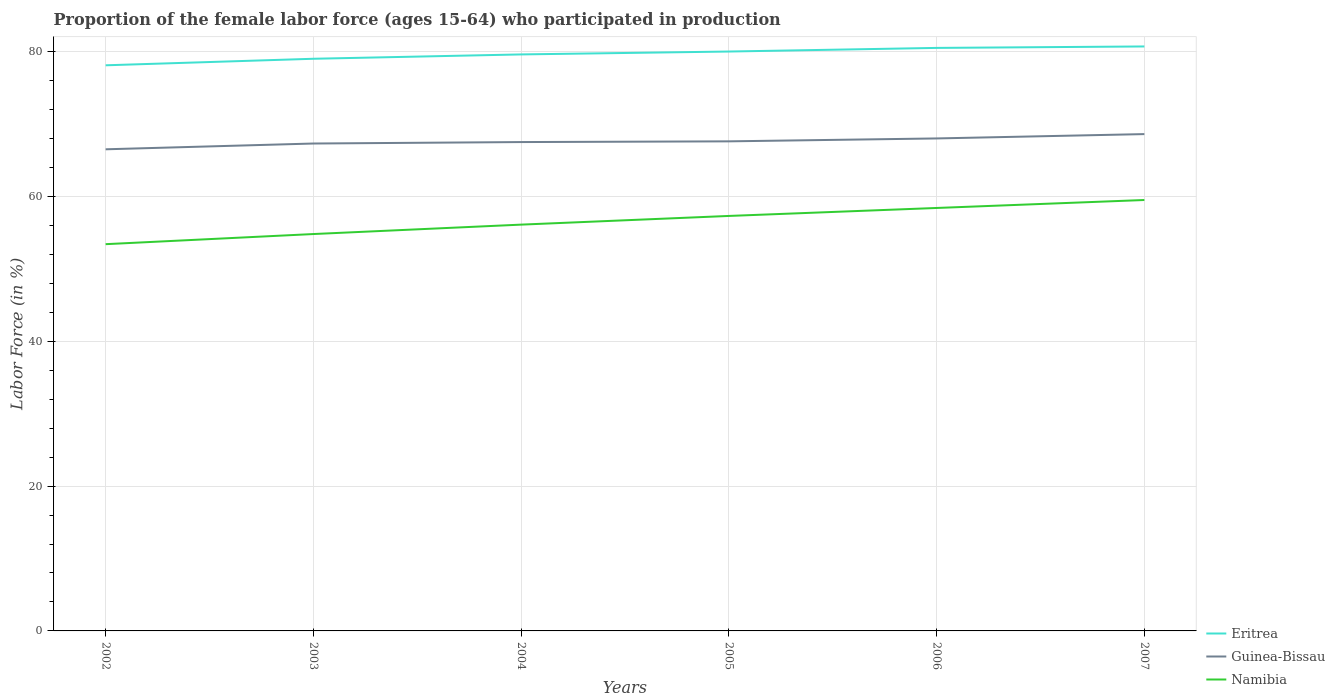How many different coloured lines are there?
Your answer should be very brief. 3. Across all years, what is the maximum proportion of the female labor force who participated in production in Namibia?
Give a very brief answer. 53.4. What is the total proportion of the female labor force who participated in production in Eritrea in the graph?
Offer a very short reply. -2.4. What is the difference between the highest and the second highest proportion of the female labor force who participated in production in Eritrea?
Provide a short and direct response. 2.6. How many lines are there?
Your response must be concise. 3. How many years are there in the graph?
Your answer should be very brief. 6. What is the difference between two consecutive major ticks on the Y-axis?
Offer a terse response. 20. Are the values on the major ticks of Y-axis written in scientific E-notation?
Make the answer very short. No. Does the graph contain any zero values?
Your answer should be very brief. No. How many legend labels are there?
Your response must be concise. 3. How are the legend labels stacked?
Give a very brief answer. Vertical. What is the title of the graph?
Keep it short and to the point. Proportion of the female labor force (ages 15-64) who participated in production. What is the label or title of the Y-axis?
Ensure brevity in your answer.  Labor Force (in %). What is the Labor Force (in %) of Eritrea in 2002?
Ensure brevity in your answer.  78.1. What is the Labor Force (in %) in Guinea-Bissau in 2002?
Your answer should be compact. 66.5. What is the Labor Force (in %) in Namibia in 2002?
Offer a very short reply. 53.4. What is the Labor Force (in %) of Eritrea in 2003?
Your answer should be compact. 79. What is the Labor Force (in %) in Guinea-Bissau in 2003?
Ensure brevity in your answer.  67.3. What is the Labor Force (in %) in Namibia in 2003?
Your answer should be very brief. 54.8. What is the Labor Force (in %) in Eritrea in 2004?
Your response must be concise. 79.6. What is the Labor Force (in %) of Guinea-Bissau in 2004?
Provide a short and direct response. 67.5. What is the Labor Force (in %) in Namibia in 2004?
Provide a short and direct response. 56.1. What is the Labor Force (in %) in Guinea-Bissau in 2005?
Ensure brevity in your answer.  67.6. What is the Labor Force (in %) of Namibia in 2005?
Make the answer very short. 57.3. What is the Labor Force (in %) in Eritrea in 2006?
Your response must be concise. 80.5. What is the Labor Force (in %) in Namibia in 2006?
Your response must be concise. 58.4. What is the Labor Force (in %) of Eritrea in 2007?
Provide a succinct answer. 80.7. What is the Labor Force (in %) in Guinea-Bissau in 2007?
Your answer should be compact. 68.6. What is the Labor Force (in %) of Namibia in 2007?
Your answer should be compact. 59.5. Across all years, what is the maximum Labor Force (in %) of Eritrea?
Make the answer very short. 80.7. Across all years, what is the maximum Labor Force (in %) of Guinea-Bissau?
Provide a short and direct response. 68.6. Across all years, what is the maximum Labor Force (in %) in Namibia?
Your answer should be compact. 59.5. Across all years, what is the minimum Labor Force (in %) in Eritrea?
Ensure brevity in your answer.  78.1. Across all years, what is the minimum Labor Force (in %) of Guinea-Bissau?
Your answer should be very brief. 66.5. Across all years, what is the minimum Labor Force (in %) in Namibia?
Your answer should be very brief. 53.4. What is the total Labor Force (in %) of Eritrea in the graph?
Offer a terse response. 477.9. What is the total Labor Force (in %) in Guinea-Bissau in the graph?
Give a very brief answer. 405.5. What is the total Labor Force (in %) in Namibia in the graph?
Ensure brevity in your answer.  339.5. What is the difference between the Labor Force (in %) of Eritrea in 2002 and that in 2003?
Offer a very short reply. -0.9. What is the difference between the Labor Force (in %) of Guinea-Bissau in 2002 and that in 2003?
Your response must be concise. -0.8. What is the difference between the Labor Force (in %) of Namibia in 2002 and that in 2003?
Your response must be concise. -1.4. What is the difference between the Labor Force (in %) in Eritrea in 2002 and that in 2004?
Offer a terse response. -1.5. What is the difference between the Labor Force (in %) of Guinea-Bissau in 2002 and that in 2004?
Provide a short and direct response. -1. What is the difference between the Labor Force (in %) in Eritrea in 2002 and that in 2006?
Give a very brief answer. -2.4. What is the difference between the Labor Force (in %) of Eritrea in 2002 and that in 2007?
Offer a very short reply. -2.6. What is the difference between the Labor Force (in %) of Namibia in 2002 and that in 2007?
Give a very brief answer. -6.1. What is the difference between the Labor Force (in %) of Eritrea in 2003 and that in 2004?
Offer a very short reply. -0.6. What is the difference between the Labor Force (in %) of Guinea-Bissau in 2003 and that in 2004?
Offer a very short reply. -0.2. What is the difference between the Labor Force (in %) of Namibia in 2003 and that in 2004?
Ensure brevity in your answer.  -1.3. What is the difference between the Labor Force (in %) of Guinea-Bissau in 2003 and that in 2005?
Make the answer very short. -0.3. What is the difference between the Labor Force (in %) in Namibia in 2003 and that in 2005?
Provide a succinct answer. -2.5. What is the difference between the Labor Force (in %) of Guinea-Bissau in 2003 and that in 2006?
Your answer should be compact. -0.7. What is the difference between the Labor Force (in %) of Namibia in 2003 and that in 2006?
Make the answer very short. -3.6. What is the difference between the Labor Force (in %) in Eritrea in 2003 and that in 2007?
Give a very brief answer. -1.7. What is the difference between the Labor Force (in %) in Guinea-Bissau in 2003 and that in 2007?
Give a very brief answer. -1.3. What is the difference between the Labor Force (in %) in Namibia in 2003 and that in 2007?
Provide a succinct answer. -4.7. What is the difference between the Labor Force (in %) of Namibia in 2004 and that in 2005?
Your response must be concise. -1.2. What is the difference between the Labor Force (in %) of Eritrea in 2004 and that in 2006?
Keep it short and to the point. -0.9. What is the difference between the Labor Force (in %) of Guinea-Bissau in 2004 and that in 2006?
Offer a terse response. -0.5. What is the difference between the Labor Force (in %) in Guinea-Bissau in 2004 and that in 2007?
Give a very brief answer. -1.1. What is the difference between the Labor Force (in %) in Namibia in 2005 and that in 2006?
Make the answer very short. -1.1. What is the difference between the Labor Force (in %) of Eritrea in 2005 and that in 2007?
Provide a short and direct response. -0.7. What is the difference between the Labor Force (in %) in Eritrea in 2006 and that in 2007?
Offer a very short reply. -0.2. What is the difference between the Labor Force (in %) of Guinea-Bissau in 2006 and that in 2007?
Provide a short and direct response. -0.6. What is the difference between the Labor Force (in %) in Namibia in 2006 and that in 2007?
Provide a short and direct response. -1.1. What is the difference between the Labor Force (in %) of Eritrea in 2002 and the Labor Force (in %) of Namibia in 2003?
Keep it short and to the point. 23.3. What is the difference between the Labor Force (in %) of Guinea-Bissau in 2002 and the Labor Force (in %) of Namibia in 2003?
Make the answer very short. 11.7. What is the difference between the Labor Force (in %) in Eritrea in 2002 and the Labor Force (in %) in Namibia in 2004?
Give a very brief answer. 22. What is the difference between the Labor Force (in %) of Guinea-Bissau in 2002 and the Labor Force (in %) of Namibia in 2004?
Your answer should be compact. 10.4. What is the difference between the Labor Force (in %) in Eritrea in 2002 and the Labor Force (in %) in Namibia in 2005?
Offer a very short reply. 20.8. What is the difference between the Labor Force (in %) of Eritrea in 2002 and the Labor Force (in %) of Guinea-Bissau in 2007?
Make the answer very short. 9.5. What is the difference between the Labor Force (in %) in Eritrea in 2002 and the Labor Force (in %) in Namibia in 2007?
Provide a short and direct response. 18.6. What is the difference between the Labor Force (in %) in Eritrea in 2003 and the Labor Force (in %) in Guinea-Bissau in 2004?
Offer a terse response. 11.5. What is the difference between the Labor Force (in %) of Eritrea in 2003 and the Labor Force (in %) of Namibia in 2004?
Make the answer very short. 22.9. What is the difference between the Labor Force (in %) of Eritrea in 2003 and the Labor Force (in %) of Namibia in 2005?
Keep it short and to the point. 21.7. What is the difference between the Labor Force (in %) of Guinea-Bissau in 2003 and the Labor Force (in %) of Namibia in 2005?
Offer a very short reply. 10. What is the difference between the Labor Force (in %) of Eritrea in 2003 and the Labor Force (in %) of Guinea-Bissau in 2006?
Offer a terse response. 11. What is the difference between the Labor Force (in %) of Eritrea in 2003 and the Labor Force (in %) of Namibia in 2006?
Provide a short and direct response. 20.6. What is the difference between the Labor Force (in %) of Eritrea in 2003 and the Labor Force (in %) of Guinea-Bissau in 2007?
Offer a terse response. 10.4. What is the difference between the Labor Force (in %) of Guinea-Bissau in 2003 and the Labor Force (in %) of Namibia in 2007?
Your answer should be very brief. 7.8. What is the difference between the Labor Force (in %) in Eritrea in 2004 and the Labor Force (in %) in Guinea-Bissau in 2005?
Give a very brief answer. 12. What is the difference between the Labor Force (in %) of Eritrea in 2004 and the Labor Force (in %) of Namibia in 2005?
Offer a very short reply. 22.3. What is the difference between the Labor Force (in %) of Eritrea in 2004 and the Labor Force (in %) of Guinea-Bissau in 2006?
Your answer should be compact. 11.6. What is the difference between the Labor Force (in %) of Eritrea in 2004 and the Labor Force (in %) of Namibia in 2006?
Make the answer very short. 21.2. What is the difference between the Labor Force (in %) of Eritrea in 2004 and the Labor Force (in %) of Namibia in 2007?
Make the answer very short. 20.1. What is the difference between the Labor Force (in %) in Eritrea in 2005 and the Labor Force (in %) in Namibia in 2006?
Your answer should be very brief. 21.6. What is the difference between the Labor Force (in %) of Guinea-Bissau in 2005 and the Labor Force (in %) of Namibia in 2007?
Provide a succinct answer. 8.1. What is the average Labor Force (in %) of Eritrea per year?
Your answer should be very brief. 79.65. What is the average Labor Force (in %) in Guinea-Bissau per year?
Provide a short and direct response. 67.58. What is the average Labor Force (in %) in Namibia per year?
Keep it short and to the point. 56.58. In the year 2002, what is the difference between the Labor Force (in %) of Eritrea and Labor Force (in %) of Guinea-Bissau?
Your answer should be compact. 11.6. In the year 2002, what is the difference between the Labor Force (in %) in Eritrea and Labor Force (in %) in Namibia?
Give a very brief answer. 24.7. In the year 2002, what is the difference between the Labor Force (in %) of Guinea-Bissau and Labor Force (in %) of Namibia?
Make the answer very short. 13.1. In the year 2003, what is the difference between the Labor Force (in %) in Eritrea and Labor Force (in %) in Namibia?
Give a very brief answer. 24.2. In the year 2004, what is the difference between the Labor Force (in %) of Guinea-Bissau and Labor Force (in %) of Namibia?
Ensure brevity in your answer.  11.4. In the year 2005, what is the difference between the Labor Force (in %) in Eritrea and Labor Force (in %) in Guinea-Bissau?
Offer a very short reply. 12.4. In the year 2005, what is the difference between the Labor Force (in %) of Eritrea and Labor Force (in %) of Namibia?
Your answer should be compact. 22.7. In the year 2006, what is the difference between the Labor Force (in %) in Eritrea and Labor Force (in %) in Namibia?
Your answer should be compact. 22.1. In the year 2007, what is the difference between the Labor Force (in %) in Eritrea and Labor Force (in %) in Guinea-Bissau?
Your answer should be very brief. 12.1. In the year 2007, what is the difference between the Labor Force (in %) of Eritrea and Labor Force (in %) of Namibia?
Give a very brief answer. 21.2. In the year 2007, what is the difference between the Labor Force (in %) of Guinea-Bissau and Labor Force (in %) of Namibia?
Your answer should be very brief. 9.1. What is the ratio of the Labor Force (in %) in Guinea-Bissau in 2002 to that in 2003?
Offer a very short reply. 0.99. What is the ratio of the Labor Force (in %) in Namibia in 2002 to that in 2003?
Offer a very short reply. 0.97. What is the ratio of the Labor Force (in %) of Eritrea in 2002 to that in 2004?
Provide a succinct answer. 0.98. What is the ratio of the Labor Force (in %) of Guinea-Bissau in 2002 to that in 2004?
Provide a short and direct response. 0.99. What is the ratio of the Labor Force (in %) of Namibia in 2002 to that in 2004?
Offer a terse response. 0.95. What is the ratio of the Labor Force (in %) in Eritrea in 2002 to that in 2005?
Your response must be concise. 0.98. What is the ratio of the Labor Force (in %) of Guinea-Bissau in 2002 to that in 2005?
Make the answer very short. 0.98. What is the ratio of the Labor Force (in %) of Namibia in 2002 to that in 2005?
Offer a very short reply. 0.93. What is the ratio of the Labor Force (in %) of Eritrea in 2002 to that in 2006?
Provide a succinct answer. 0.97. What is the ratio of the Labor Force (in %) of Guinea-Bissau in 2002 to that in 2006?
Give a very brief answer. 0.98. What is the ratio of the Labor Force (in %) of Namibia in 2002 to that in 2006?
Your answer should be very brief. 0.91. What is the ratio of the Labor Force (in %) of Eritrea in 2002 to that in 2007?
Give a very brief answer. 0.97. What is the ratio of the Labor Force (in %) in Guinea-Bissau in 2002 to that in 2007?
Give a very brief answer. 0.97. What is the ratio of the Labor Force (in %) of Namibia in 2002 to that in 2007?
Give a very brief answer. 0.9. What is the ratio of the Labor Force (in %) in Guinea-Bissau in 2003 to that in 2004?
Your answer should be very brief. 1. What is the ratio of the Labor Force (in %) of Namibia in 2003 to that in 2004?
Offer a very short reply. 0.98. What is the ratio of the Labor Force (in %) in Eritrea in 2003 to that in 2005?
Offer a terse response. 0.99. What is the ratio of the Labor Force (in %) of Guinea-Bissau in 2003 to that in 2005?
Your answer should be compact. 1. What is the ratio of the Labor Force (in %) in Namibia in 2003 to that in 2005?
Make the answer very short. 0.96. What is the ratio of the Labor Force (in %) in Eritrea in 2003 to that in 2006?
Offer a very short reply. 0.98. What is the ratio of the Labor Force (in %) in Namibia in 2003 to that in 2006?
Give a very brief answer. 0.94. What is the ratio of the Labor Force (in %) of Eritrea in 2003 to that in 2007?
Make the answer very short. 0.98. What is the ratio of the Labor Force (in %) in Guinea-Bissau in 2003 to that in 2007?
Make the answer very short. 0.98. What is the ratio of the Labor Force (in %) in Namibia in 2003 to that in 2007?
Offer a terse response. 0.92. What is the ratio of the Labor Force (in %) of Eritrea in 2004 to that in 2005?
Ensure brevity in your answer.  0.99. What is the ratio of the Labor Force (in %) in Guinea-Bissau in 2004 to that in 2005?
Keep it short and to the point. 1. What is the ratio of the Labor Force (in %) of Namibia in 2004 to that in 2005?
Provide a short and direct response. 0.98. What is the ratio of the Labor Force (in %) in Eritrea in 2004 to that in 2006?
Your answer should be very brief. 0.99. What is the ratio of the Labor Force (in %) of Guinea-Bissau in 2004 to that in 2006?
Give a very brief answer. 0.99. What is the ratio of the Labor Force (in %) in Namibia in 2004 to that in 2006?
Provide a succinct answer. 0.96. What is the ratio of the Labor Force (in %) of Eritrea in 2004 to that in 2007?
Give a very brief answer. 0.99. What is the ratio of the Labor Force (in %) in Guinea-Bissau in 2004 to that in 2007?
Give a very brief answer. 0.98. What is the ratio of the Labor Force (in %) in Namibia in 2004 to that in 2007?
Offer a terse response. 0.94. What is the ratio of the Labor Force (in %) of Eritrea in 2005 to that in 2006?
Offer a very short reply. 0.99. What is the ratio of the Labor Force (in %) in Guinea-Bissau in 2005 to that in 2006?
Keep it short and to the point. 0.99. What is the ratio of the Labor Force (in %) of Namibia in 2005 to that in 2006?
Provide a short and direct response. 0.98. What is the ratio of the Labor Force (in %) of Eritrea in 2005 to that in 2007?
Offer a terse response. 0.99. What is the ratio of the Labor Force (in %) of Guinea-Bissau in 2005 to that in 2007?
Your response must be concise. 0.99. What is the ratio of the Labor Force (in %) of Eritrea in 2006 to that in 2007?
Provide a short and direct response. 1. What is the ratio of the Labor Force (in %) in Namibia in 2006 to that in 2007?
Offer a terse response. 0.98. What is the difference between the highest and the second highest Labor Force (in %) of Eritrea?
Make the answer very short. 0.2. What is the difference between the highest and the second highest Labor Force (in %) in Guinea-Bissau?
Give a very brief answer. 0.6. What is the difference between the highest and the lowest Labor Force (in %) in Guinea-Bissau?
Give a very brief answer. 2.1. What is the difference between the highest and the lowest Labor Force (in %) in Namibia?
Give a very brief answer. 6.1. 